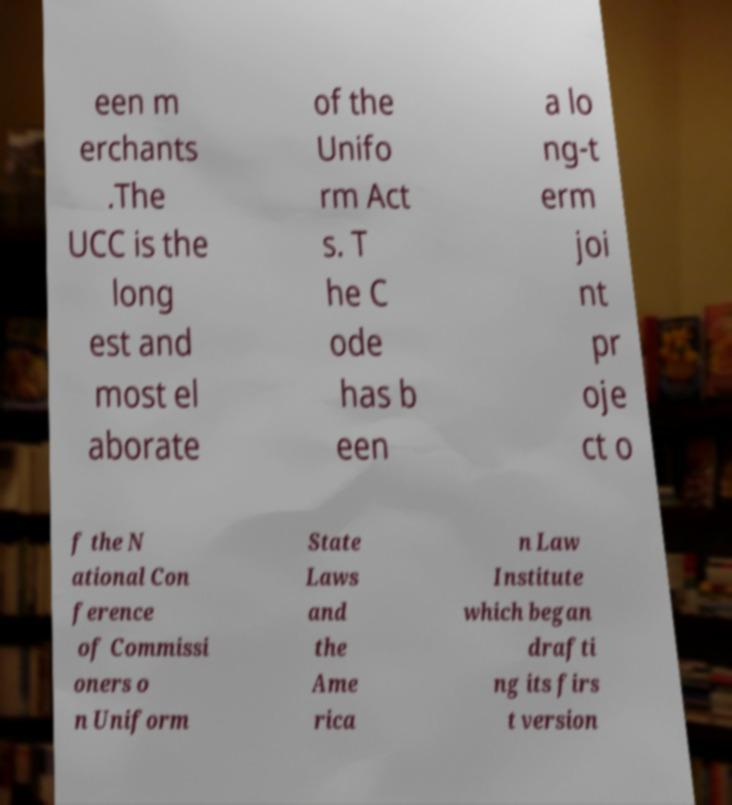I need the written content from this picture converted into text. Can you do that? een m erchants .The UCC is the long est and most el aborate of the Unifo rm Act s. T he C ode has b een a lo ng-t erm joi nt pr oje ct o f the N ational Con ference of Commissi oners o n Uniform State Laws and the Ame rica n Law Institute which began drafti ng its firs t version 